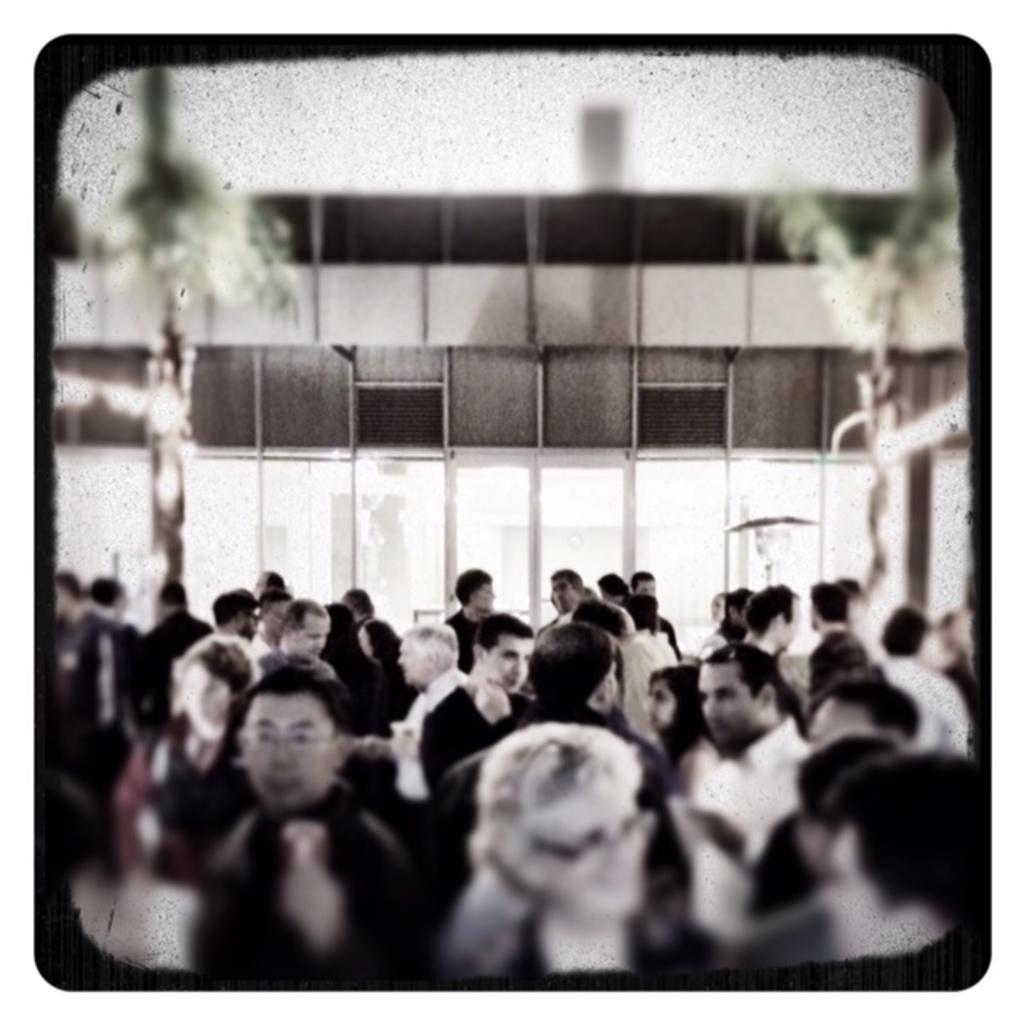Please provide a concise description of this image. In this image there are so many people in the foreground. In the background there is a building. At the top it looks like a tree on either side of the image. 